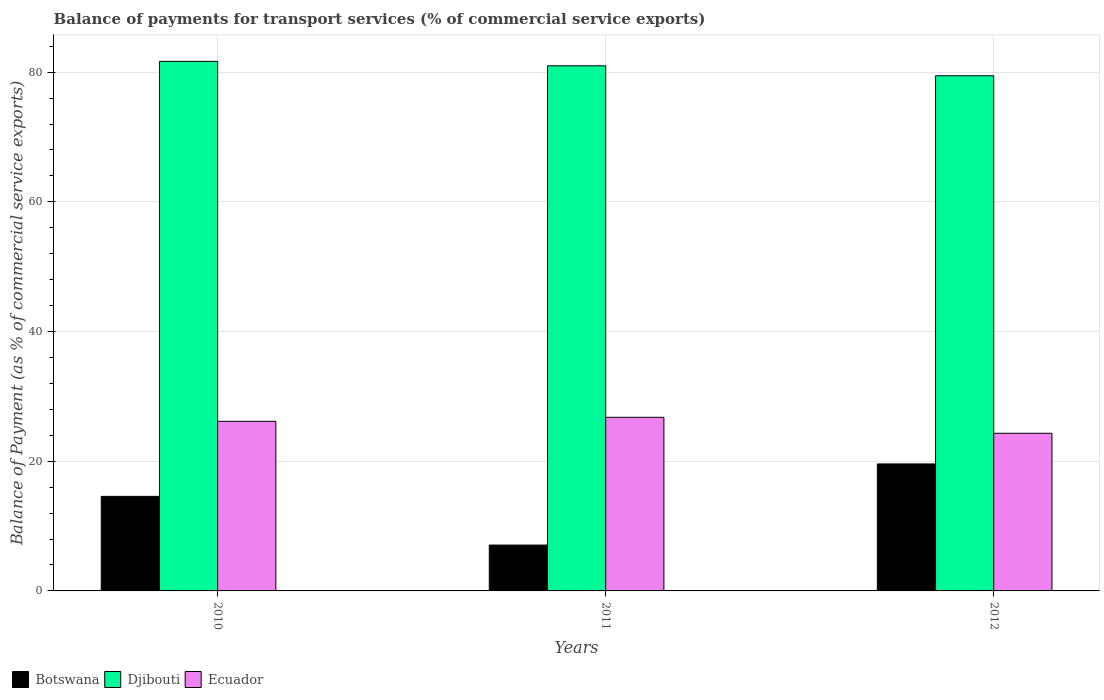How many different coloured bars are there?
Offer a terse response. 3. How many groups of bars are there?
Your answer should be compact. 3. Are the number of bars on each tick of the X-axis equal?
Offer a terse response. Yes. What is the label of the 2nd group of bars from the left?
Make the answer very short. 2011. What is the balance of payments for transport services in Ecuador in 2010?
Offer a very short reply. 26.16. Across all years, what is the maximum balance of payments for transport services in Djibouti?
Your answer should be very brief. 81.67. Across all years, what is the minimum balance of payments for transport services in Ecuador?
Keep it short and to the point. 24.31. In which year was the balance of payments for transport services in Djibouti maximum?
Make the answer very short. 2010. What is the total balance of payments for transport services in Ecuador in the graph?
Keep it short and to the point. 77.25. What is the difference between the balance of payments for transport services in Botswana in 2010 and that in 2012?
Provide a short and direct response. -5. What is the difference between the balance of payments for transport services in Botswana in 2011 and the balance of payments for transport services in Djibouti in 2010?
Ensure brevity in your answer.  -74.6. What is the average balance of payments for transport services in Djibouti per year?
Provide a short and direct response. 80.7. In the year 2012, what is the difference between the balance of payments for transport services in Botswana and balance of payments for transport services in Djibouti?
Offer a very short reply. -59.86. In how many years, is the balance of payments for transport services in Ecuador greater than 56 %?
Offer a terse response. 0. What is the ratio of the balance of payments for transport services in Djibouti in 2010 to that in 2012?
Your answer should be very brief. 1.03. Is the balance of payments for transport services in Botswana in 2010 less than that in 2011?
Offer a very short reply. No. What is the difference between the highest and the second highest balance of payments for transport services in Botswana?
Your answer should be very brief. 5. What is the difference between the highest and the lowest balance of payments for transport services in Botswana?
Give a very brief answer. 12.51. Is the sum of the balance of payments for transport services in Djibouti in 2010 and 2011 greater than the maximum balance of payments for transport services in Ecuador across all years?
Provide a short and direct response. Yes. What does the 1st bar from the left in 2011 represents?
Your answer should be very brief. Botswana. What does the 3rd bar from the right in 2012 represents?
Your response must be concise. Botswana. Is it the case that in every year, the sum of the balance of payments for transport services in Ecuador and balance of payments for transport services in Botswana is greater than the balance of payments for transport services in Djibouti?
Give a very brief answer. No. Are all the bars in the graph horizontal?
Give a very brief answer. No. Are the values on the major ticks of Y-axis written in scientific E-notation?
Offer a terse response. No. Does the graph contain any zero values?
Provide a succinct answer. No. Does the graph contain grids?
Offer a very short reply. Yes. How many legend labels are there?
Your answer should be compact. 3. What is the title of the graph?
Your answer should be very brief. Balance of payments for transport services (% of commercial service exports). Does "Iceland" appear as one of the legend labels in the graph?
Provide a short and direct response. No. What is the label or title of the Y-axis?
Provide a short and direct response. Balance of Payment (as % of commercial service exports). What is the Balance of Payment (as % of commercial service exports) in Botswana in 2010?
Provide a short and direct response. 14.58. What is the Balance of Payment (as % of commercial service exports) in Djibouti in 2010?
Give a very brief answer. 81.67. What is the Balance of Payment (as % of commercial service exports) of Ecuador in 2010?
Provide a short and direct response. 26.16. What is the Balance of Payment (as % of commercial service exports) of Botswana in 2011?
Your answer should be compact. 7.07. What is the Balance of Payment (as % of commercial service exports) of Djibouti in 2011?
Your answer should be very brief. 80.98. What is the Balance of Payment (as % of commercial service exports) in Ecuador in 2011?
Offer a very short reply. 26.78. What is the Balance of Payment (as % of commercial service exports) in Botswana in 2012?
Your answer should be compact. 19.58. What is the Balance of Payment (as % of commercial service exports) in Djibouti in 2012?
Ensure brevity in your answer.  79.45. What is the Balance of Payment (as % of commercial service exports) in Ecuador in 2012?
Offer a terse response. 24.31. Across all years, what is the maximum Balance of Payment (as % of commercial service exports) of Botswana?
Your answer should be compact. 19.58. Across all years, what is the maximum Balance of Payment (as % of commercial service exports) in Djibouti?
Ensure brevity in your answer.  81.67. Across all years, what is the maximum Balance of Payment (as % of commercial service exports) of Ecuador?
Keep it short and to the point. 26.78. Across all years, what is the minimum Balance of Payment (as % of commercial service exports) of Botswana?
Offer a terse response. 7.07. Across all years, what is the minimum Balance of Payment (as % of commercial service exports) of Djibouti?
Make the answer very short. 79.45. Across all years, what is the minimum Balance of Payment (as % of commercial service exports) in Ecuador?
Your answer should be compact. 24.31. What is the total Balance of Payment (as % of commercial service exports) in Botswana in the graph?
Keep it short and to the point. 41.24. What is the total Balance of Payment (as % of commercial service exports) of Djibouti in the graph?
Ensure brevity in your answer.  242.1. What is the total Balance of Payment (as % of commercial service exports) in Ecuador in the graph?
Ensure brevity in your answer.  77.25. What is the difference between the Balance of Payment (as % of commercial service exports) of Botswana in 2010 and that in 2011?
Give a very brief answer. 7.51. What is the difference between the Balance of Payment (as % of commercial service exports) in Djibouti in 2010 and that in 2011?
Provide a short and direct response. 0.69. What is the difference between the Balance of Payment (as % of commercial service exports) in Ecuador in 2010 and that in 2011?
Give a very brief answer. -0.62. What is the difference between the Balance of Payment (as % of commercial service exports) of Botswana in 2010 and that in 2012?
Your answer should be very brief. -5. What is the difference between the Balance of Payment (as % of commercial service exports) in Djibouti in 2010 and that in 2012?
Keep it short and to the point. 2.22. What is the difference between the Balance of Payment (as % of commercial service exports) of Ecuador in 2010 and that in 2012?
Provide a succinct answer. 1.84. What is the difference between the Balance of Payment (as % of commercial service exports) of Botswana in 2011 and that in 2012?
Your response must be concise. -12.51. What is the difference between the Balance of Payment (as % of commercial service exports) in Djibouti in 2011 and that in 2012?
Offer a very short reply. 1.53. What is the difference between the Balance of Payment (as % of commercial service exports) of Ecuador in 2011 and that in 2012?
Ensure brevity in your answer.  2.46. What is the difference between the Balance of Payment (as % of commercial service exports) in Botswana in 2010 and the Balance of Payment (as % of commercial service exports) in Djibouti in 2011?
Offer a terse response. -66.4. What is the difference between the Balance of Payment (as % of commercial service exports) of Botswana in 2010 and the Balance of Payment (as % of commercial service exports) of Ecuador in 2011?
Provide a succinct answer. -12.19. What is the difference between the Balance of Payment (as % of commercial service exports) of Djibouti in 2010 and the Balance of Payment (as % of commercial service exports) of Ecuador in 2011?
Provide a succinct answer. 54.89. What is the difference between the Balance of Payment (as % of commercial service exports) in Botswana in 2010 and the Balance of Payment (as % of commercial service exports) in Djibouti in 2012?
Ensure brevity in your answer.  -64.87. What is the difference between the Balance of Payment (as % of commercial service exports) in Botswana in 2010 and the Balance of Payment (as % of commercial service exports) in Ecuador in 2012?
Give a very brief answer. -9.73. What is the difference between the Balance of Payment (as % of commercial service exports) of Djibouti in 2010 and the Balance of Payment (as % of commercial service exports) of Ecuador in 2012?
Provide a short and direct response. 57.36. What is the difference between the Balance of Payment (as % of commercial service exports) of Botswana in 2011 and the Balance of Payment (as % of commercial service exports) of Djibouti in 2012?
Your answer should be very brief. -72.37. What is the difference between the Balance of Payment (as % of commercial service exports) in Botswana in 2011 and the Balance of Payment (as % of commercial service exports) in Ecuador in 2012?
Keep it short and to the point. -17.24. What is the difference between the Balance of Payment (as % of commercial service exports) of Djibouti in 2011 and the Balance of Payment (as % of commercial service exports) of Ecuador in 2012?
Your answer should be compact. 56.67. What is the average Balance of Payment (as % of commercial service exports) of Botswana per year?
Ensure brevity in your answer.  13.75. What is the average Balance of Payment (as % of commercial service exports) in Djibouti per year?
Your answer should be very brief. 80.7. What is the average Balance of Payment (as % of commercial service exports) of Ecuador per year?
Provide a succinct answer. 25.75. In the year 2010, what is the difference between the Balance of Payment (as % of commercial service exports) in Botswana and Balance of Payment (as % of commercial service exports) in Djibouti?
Provide a succinct answer. -67.09. In the year 2010, what is the difference between the Balance of Payment (as % of commercial service exports) of Botswana and Balance of Payment (as % of commercial service exports) of Ecuador?
Your answer should be very brief. -11.57. In the year 2010, what is the difference between the Balance of Payment (as % of commercial service exports) in Djibouti and Balance of Payment (as % of commercial service exports) in Ecuador?
Your response must be concise. 55.51. In the year 2011, what is the difference between the Balance of Payment (as % of commercial service exports) in Botswana and Balance of Payment (as % of commercial service exports) in Djibouti?
Ensure brevity in your answer.  -73.91. In the year 2011, what is the difference between the Balance of Payment (as % of commercial service exports) in Botswana and Balance of Payment (as % of commercial service exports) in Ecuador?
Provide a succinct answer. -19.7. In the year 2011, what is the difference between the Balance of Payment (as % of commercial service exports) in Djibouti and Balance of Payment (as % of commercial service exports) in Ecuador?
Your answer should be compact. 54.21. In the year 2012, what is the difference between the Balance of Payment (as % of commercial service exports) in Botswana and Balance of Payment (as % of commercial service exports) in Djibouti?
Provide a succinct answer. -59.86. In the year 2012, what is the difference between the Balance of Payment (as % of commercial service exports) of Botswana and Balance of Payment (as % of commercial service exports) of Ecuador?
Provide a succinct answer. -4.73. In the year 2012, what is the difference between the Balance of Payment (as % of commercial service exports) of Djibouti and Balance of Payment (as % of commercial service exports) of Ecuador?
Offer a very short reply. 55.14. What is the ratio of the Balance of Payment (as % of commercial service exports) in Botswana in 2010 to that in 2011?
Keep it short and to the point. 2.06. What is the ratio of the Balance of Payment (as % of commercial service exports) in Djibouti in 2010 to that in 2011?
Your answer should be compact. 1.01. What is the ratio of the Balance of Payment (as % of commercial service exports) in Ecuador in 2010 to that in 2011?
Your answer should be very brief. 0.98. What is the ratio of the Balance of Payment (as % of commercial service exports) in Botswana in 2010 to that in 2012?
Offer a very short reply. 0.74. What is the ratio of the Balance of Payment (as % of commercial service exports) in Djibouti in 2010 to that in 2012?
Your answer should be compact. 1.03. What is the ratio of the Balance of Payment (as % of commercial service exports) of Ecuador in 2010 to that in 2012?
Keep it short and to the point. 1.08. What is the ratio of the Balance of Payment (as % of commercial service exports) of Botswana in 2011 to that in 2012?
Your answer should be compact. 0.36. What is the ratio of the Balance of Payment (as % of commercial service exports) of Djibouti in 2011 to that in 2012?
Your answer should be very brief. 1.02. What is the ratio of the Balance of Payment (as % of commercial service exports) of Ecuador in 2011 to that in 2012?
Provide a short and direct response. 1.1. What is the difference between the highest and the second highest Balance of Payment (as % of commercial service exports) in Botswana?
Give a very brief answer. 5. What is the difference between the highest and the second highest Balance of Payment (as % of commercial service exports) of Djibouti?
Provide a short and direct response. 0.69. What is the difference between the highest and the second highest Balance of Payment (as % of commercial service exports) in Ecuador?
Ensure brevity in your answer.  0.62. What is the difference between the highest and the lowest Balance of Payment (as % of commercial service exports) in Botswana?
Ensure brevity in your answer.  12.51. What is the difference between the highest and the lowest Balance of Payment (as % of commercial service exports) in Djibouti?
Give a very brief answer. 2.22. What is the difference between the highest and the lowest Balance of Payment (as % of commercial service exports) of Ecuador?
Provide a short and direct response. 2.46. 